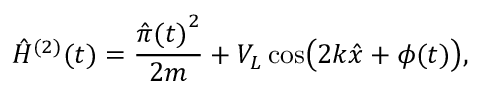Convert formula to latex. <formula><loc_0><loc_0><loc_500><loc_500>\hat { H } ^ { ( 2 ) } ( t ) = \frac { { \hat { \pi } ( t ) } ^ { 2 } } { 2 m } + V _ { L } \cos \left ( 2 k \hat { x } + \phi ( t ) \right ) ,</formula> 